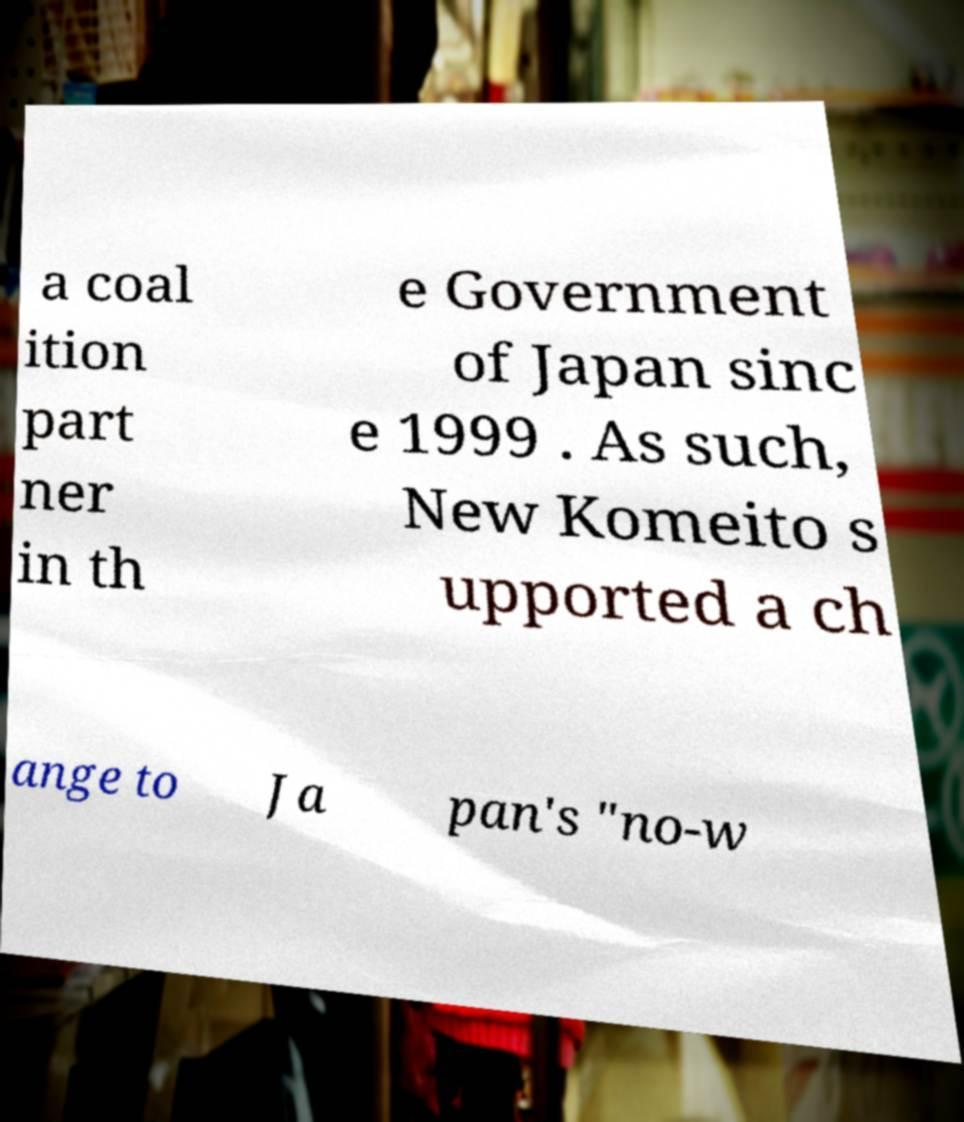What messages or text are displayed in this image? I need them in a readable, typed format. a coal ition part ner in th e Government of Japan sinc e 1999 . As such, New Komeito s upported a ch ange to Ja pan's "no-w 